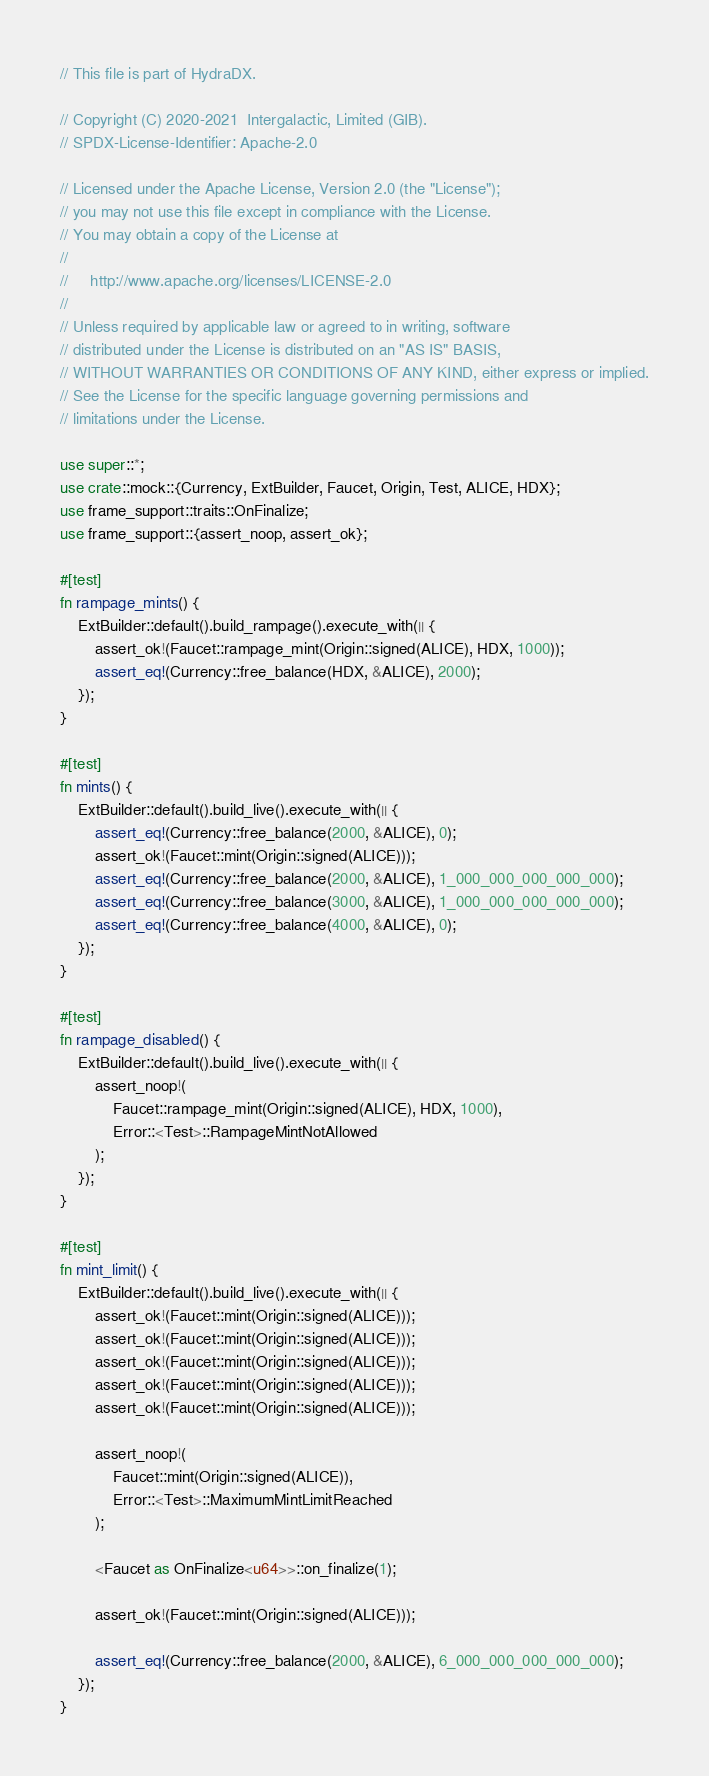<code> <loc_0><loc_0><loc_500><loc_500><_Rust_>// This file is part of HydraDX.

// Copyright (C) 2020-2021  Intergalactic, Limited (GIB).
// SPDX-License-Identifier: Apache-2.0

// Licensed under the Apache License, Version 2.0 (the "License");
// you may not use this file except in compliance with the License.
// You may obtain a copy of the License at
//
//     http://www.apache.org/licenses/LICENSE-2.0
//
// Unless required by applicable law or agreed to in writing, software
// distributed under the License is distributed on an "AS IS" BASIS,
// WITHOUT WARRANTIES OR CONDITIONS OF ANY KIND, either express or implied.
// See the License for the specific language governing permissions and
// limitations under the License.

use super::*;
use crate::mock::{Currency, ExtBuilder, Faucet, Origin, Test, ALICE, HDX};
use frame_support::traits::OnFinalize;
use frame_support::{assert_noop, assert_ok};

#[test]
fn rampage_mints() {
	ExtBuilder::default().build_rampage().execute_with(|| {
		assert_ok!(Faucet::rampage_mint(Origin::signed(ALICE), HDX, 1000));
		assert_eq!(Currency::free_balance(HDX, &ALICE), 2000);
	});
}

#[test]
fn mints() {
	ExtBuilder::default().build_live().execute_with(|| {
		assert_eq!(Currency::free_balance(2000, &ALICE), 0);
		assert_ok!(Faucet::mint(Origin::signed(ALICE)));
		assert_eq!(Currency::free_balance(2000, &ALICE), 1_000_000_000_000_000);
		assert_eq!(Currency::free_balance(3000, &ALICE), 1_000_000_000_000_000);
		assert_eq!(Currency::free_balance(4000, &ALICE), 0);
	});
}

#[test]
fn rampage_disabled() {
	ExtBuilder::default().build_live().execute_with(|| {
		assert_noop!(
			Faucet::rampage_mint(Origin::signed(ALICE), HDX, 1000),
			Error::<Test>::RampageMintNotAllowed
		);
	});
}

#[test]
fn mint_limit() {
	ExtBuilder::default().build_live().execute_with(|| {
		assert_ok!(Faucet::mint(Origin::signed(ALICE)));
		assert_ok!(Faucet::mint(Origin::signed(ALICE)));
		assert_ok!(Faucet::mint(Origin::signed(ALICE)));
		assert_ok!(Faucet::mint(Origin::signed(ALICE)));
		assert_ok!(Faucet::mint(Origin::signed(ALICE)));

		assert_noop!(
			Faucet::mint(Origin::signed(ALICE)),
			Error::<Test>::MaximumMintLimitReached
		);

		<Faucet as OnFinalize<u64>>::on_finalize(1);

		assert_ok!(Faucet::mint(Origin::signed(ALICE)));

		assert_eq!(Currency::free_balance(2000, &ALICE), 6_000_000_000_000_000);
	});
}
</code> 